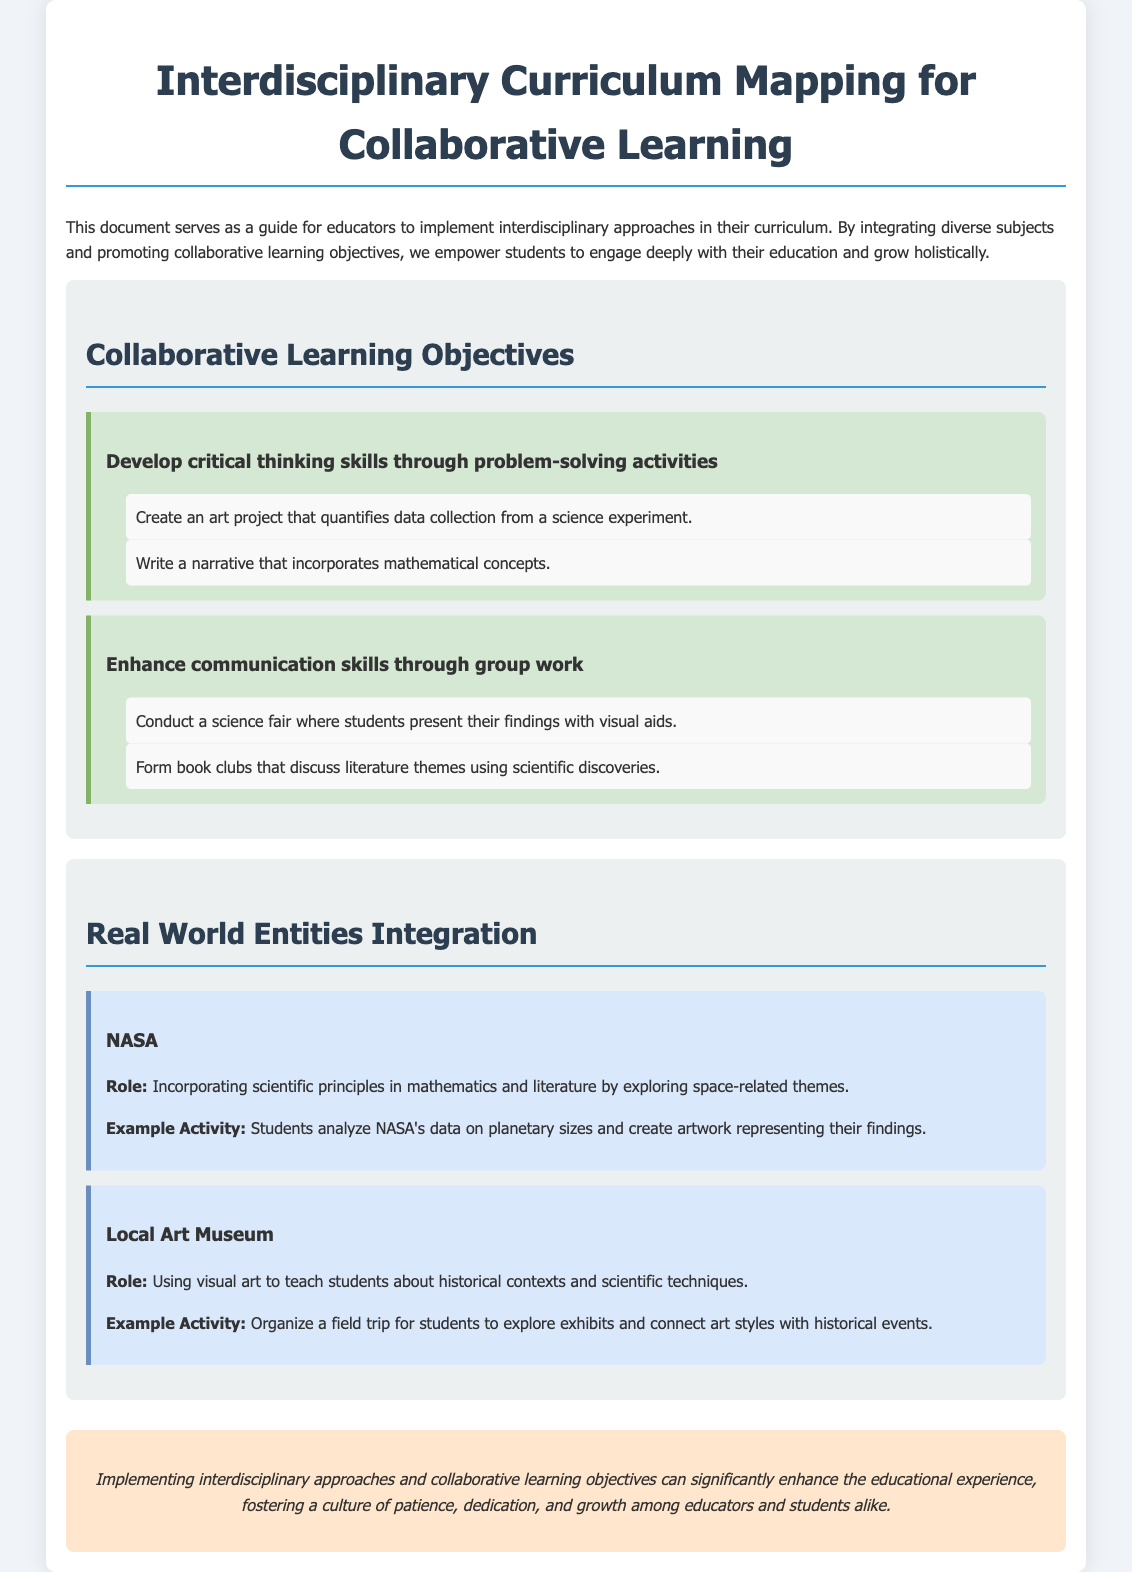What is the title of the document? The title can be found in the header of the document, stating the main topic it addresses.
Answer: Interdisciplinary Curriculum Mapping for Collaborative Learning How many collaborative learning objectives are mentioned? The document lists two collaborative learning objectives under the respective section.
Answer: 2 What organization is mentioned as a real-world entity? The document provides specific examples of entities integrated into the curriculum, with one being highlighted.
Answer: NASA What is one activity related to enhancing communication skills? The activities under each objective provide specific examples of how to enhance student skills; one such activity is detailed closely.
Answer: Conduct a science fair where students present their findings with visual aids What does the section on local entities focus on? This section describes how local entities contribute to education through specific roles and example activities.
Answer: Integration of visual art with historical contexts and scientific techniques What skill does the first collaborative learning objective aim to develop? The wording in the document outlines the focus of each objective explicitly, allowing for precise identification of the targeted skill.
Answer: Critical thinking skills What is an example activity related to NASA? The document includes specific example activities related to real-world entities, with one tied to NASA's contributions.
Answer: Students analyze NASA's data on planetary sizes and create artwork representing their findings 